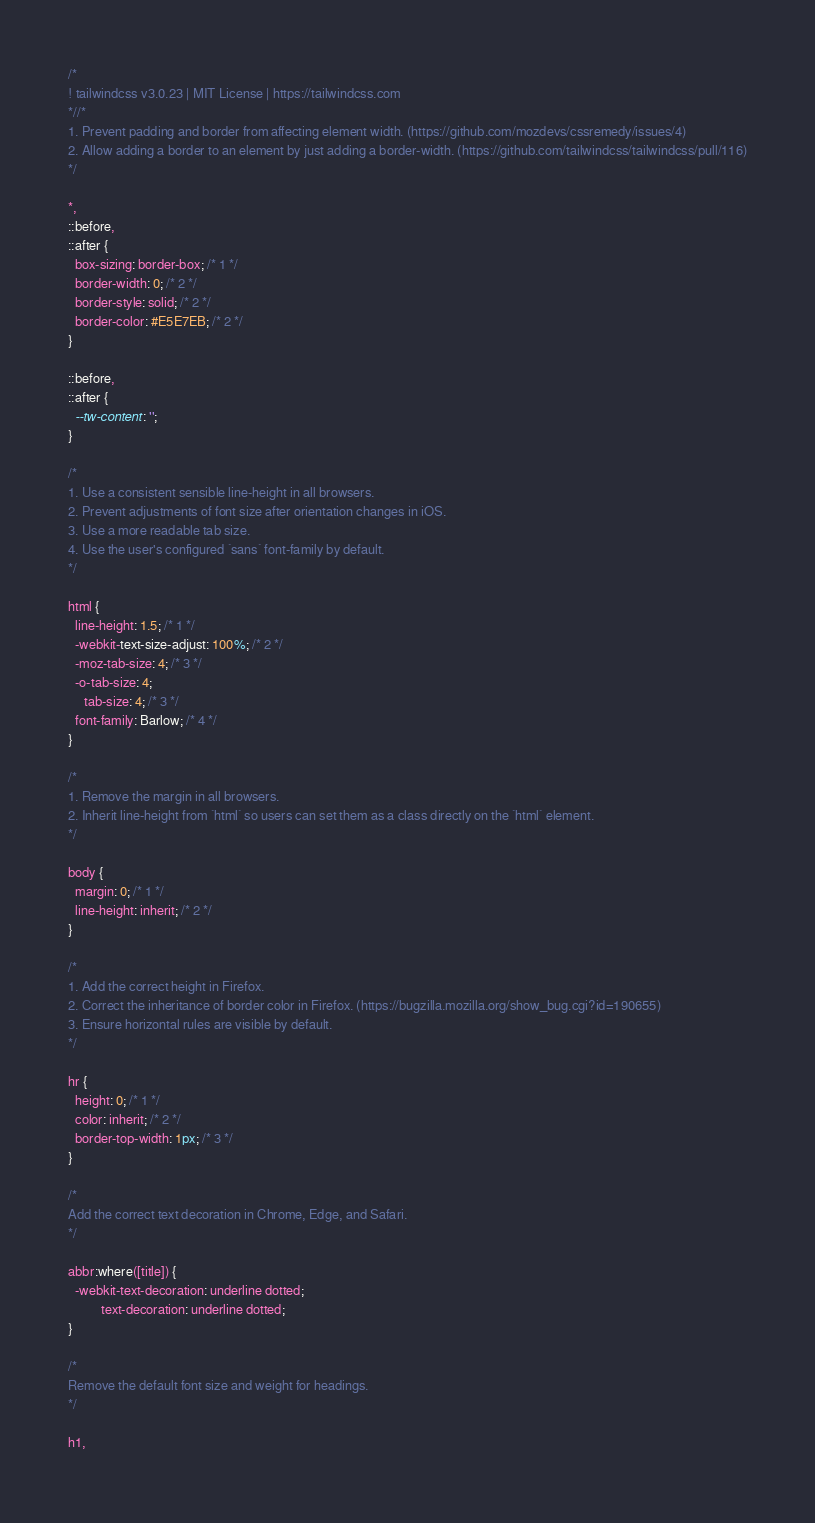Convert code to text. <code><loc_0><loc_0><loc_500><loc_500><_CSS_>/*
! tailwindcss v3.0.23 | MIT License | https://tailwindcss.com
*//*
1. Prevent padding and border from affecting element width. (https://github.com/mozdevs/cssremedy/issues/4)
2. Allow adding a border to an element by just adding a border-width. (https://github.com/tailwindcss/tailwindcss/pull/116)
*/

*,
::before,
::after {
  box-sizing: border-box; /* 1 */
  border-width: 0; /* 2 */
  border-style: solid; /* 2 */
  border-color: #E5E7EB; /* 2 */
}

::before,
::after {
  --tw-content: '';
}

/*
1. Use a consistent sensible line-height in all browsers.
2. Prevent adjustments of font size after orientation changes in iOS.
3. Use a more readable tab size.
4. Use the user's configured `sans` font-family by default.
*/

html {
  line-height: 1.5; /* 1 */
  -webkit-text-size-adjust: 100%; /* 2 */
  -moz-tab-size: 4; /* 3 */
  -o-tab-size: 4;
     tab-size: 4; /* 3 */
  font-family: Barlow; /* 4 */
}

/*
1. Remove the margin in all browsers.
2. Inherit line-height from `html` so users can set them as a class directly on the `html` element.
*/

body {
  margin: 0; /* 1 */
  line-height: inherit; /* 2 */
}

/*
1. Add the correct height in Firefox.
2. Correct the inheritance of border color in Firefox. (https://bugzilla.mozilla.org/show_bug.cgi?id=190655)
3. Ensure horizontal rules are visible by default.
*/

hr {
  height: 0; /* 1 */
  color: inherit; /* 2 */
  border-top-width: 1px; /* 3 */
}

/*
Add the correct text decoration in Chrome, Edge, and Safari.
*/

abbr:where([title]) {
  -webkit-text-decoration: underline dotted;
          text-decoration: underline dotted;
}

/*
Remove the default font size and weight for headings.
*/

h1,</code> 